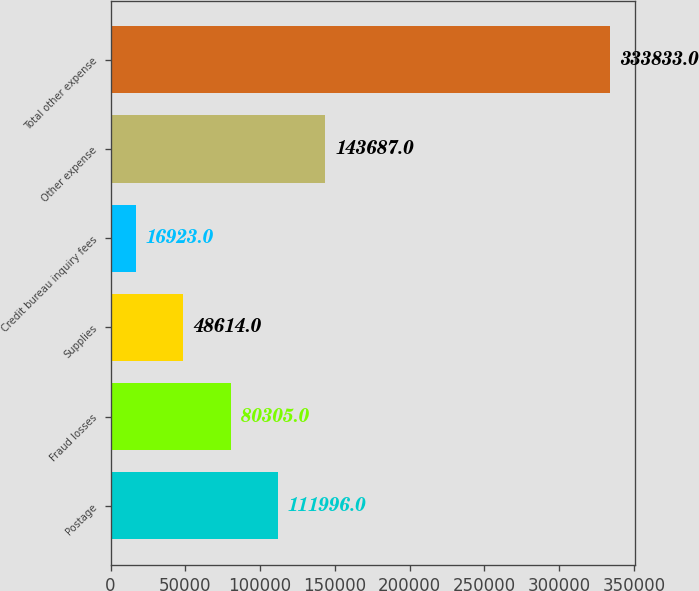<chart> <loc_0><loc_0><loc_500><loc_500><bar_chart><fcel>Postage<fcel>Fraud losses<fcel>Supplies<fcel>Credit bureau inquiry fees<fcel>Other expense<fcel>Total other expense<nl><fcel>111996<fcel>80305<fcel>48614<fcel>16923<fcel>143687<fcel>333833<nl></chart> 